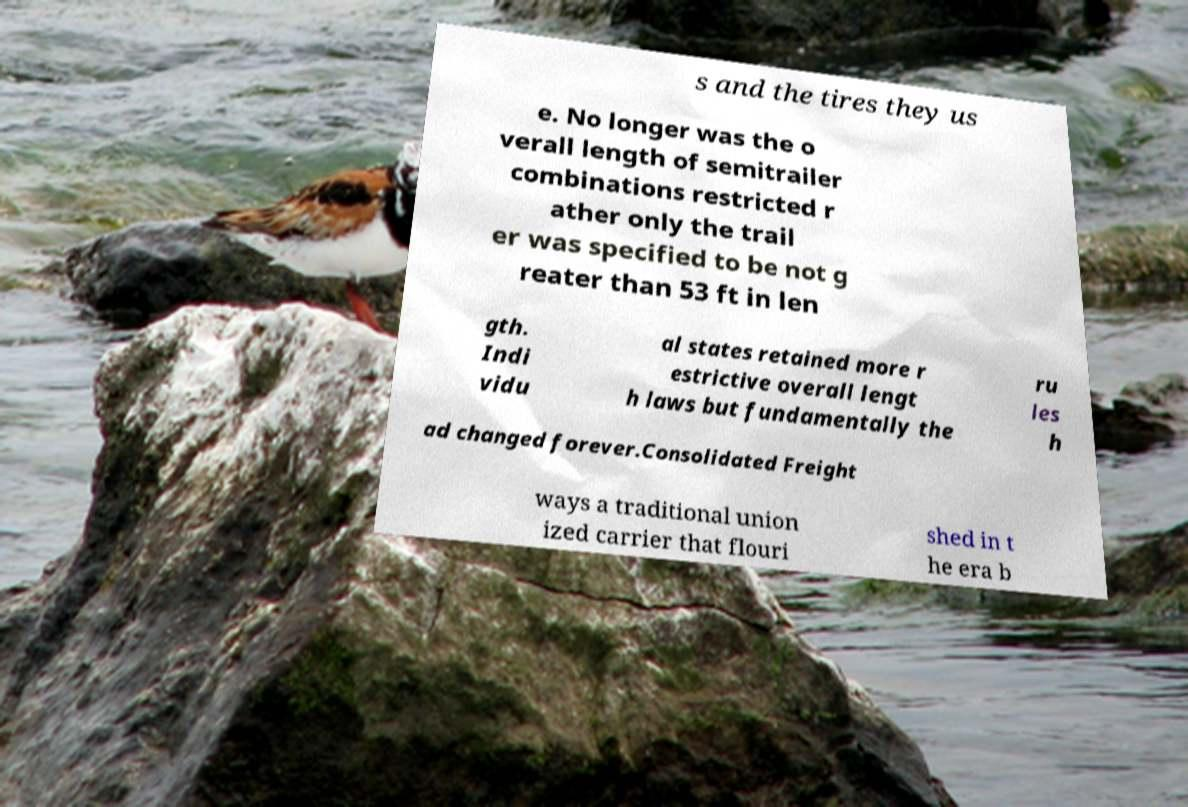Could you assist in decoding the text presented in this image and type it out clearly? s and the tires they us e. No longer was the o verall length of semitrailer combinations restricted r ather only the trail er was specified to be not g reater than 53 ft in len gth. Indi vidu al states retained more r estrictive overall lengt h laws but fundamentally the ru les h ad changed forever.Consolidated Freight ways a traditional union ized carrier that flouri shed in t he era b 